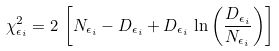<formula> <loc_0><loc_0><loc_500><loc_500>\chi ^ { 2 } _ { \epsilon _ { i } } = 2 \, \left [ N _ { \epsilon _ { i } } - D _ { \epsilon _ { i } } + D _ { \epsilon _ { i } } \, \ln \left ( \frac { D _ { \epsilon _ { i } } } { N _ { \epsilon _ { i } } } \right ) \right ]</formula> 